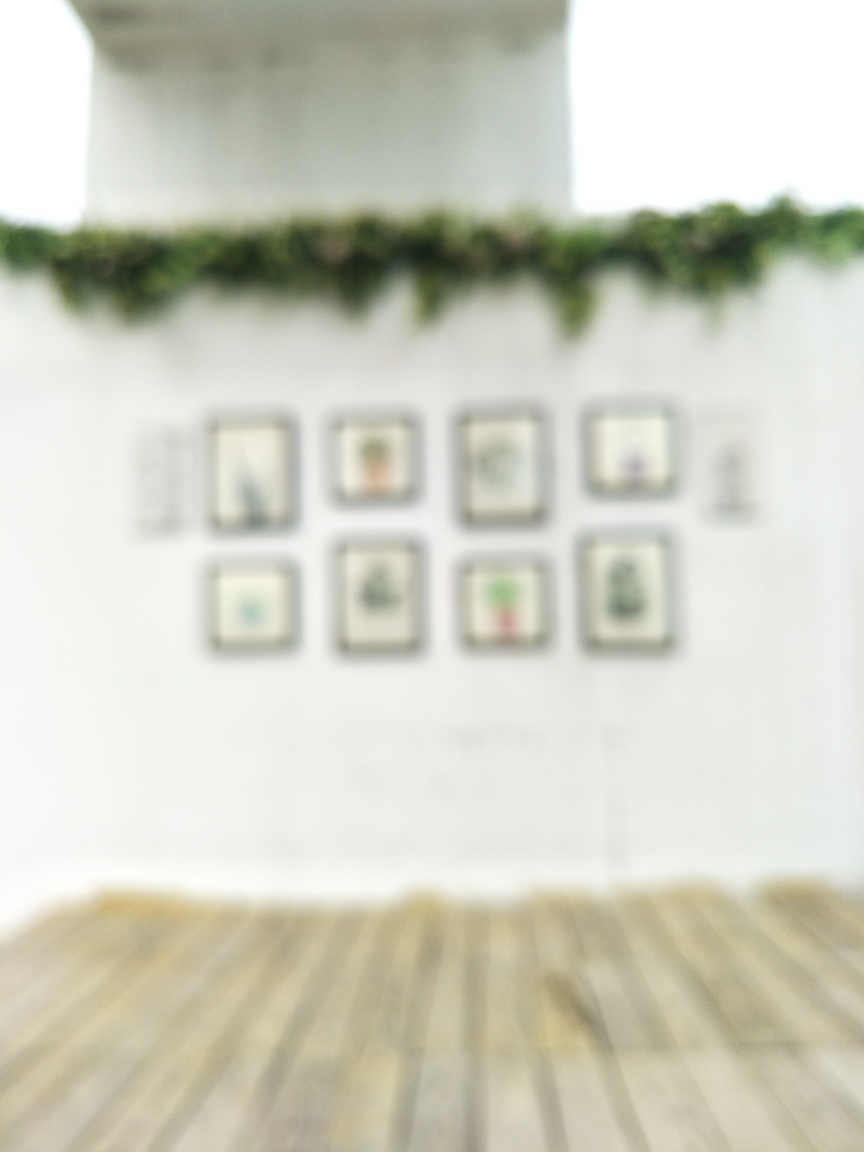How would you describe the texture details of the picture frame on the subject's wall?
A. Almost completely lost
B. Highly visible
C. Enhanced
D. Sharp and crisp
Answer with the option's letter from the given choices directly. Unfortunately, due to the image being out of focus, it is not possible to discern the texture of the picture frames on the wall with any degree of precision. Therefore, the textures of the frames are not 'highly visible,' 'enhanced,' or 'sharp and crisp,' and the most fitting description would be 'almost completely lost.' 